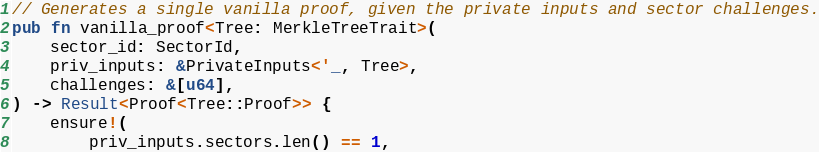Convert code to text. <code><loc_0><loc_0><loc_500><loc_500><_Rust_>// Generates a single vanilla proof, given the private inputs and sector challenges.
pub fn vanilla_proof<Tree: MerkleTreeTrait>(
    sector_id: SectorId,
    priv_inputs: &PrivateInputs<'_, Tree>,
    challenges: &[u64],
) -> Result<Proof<Tree::Proof>> {
    ensure!(
        priv_inputs.sectors.len() == 1,</code> 